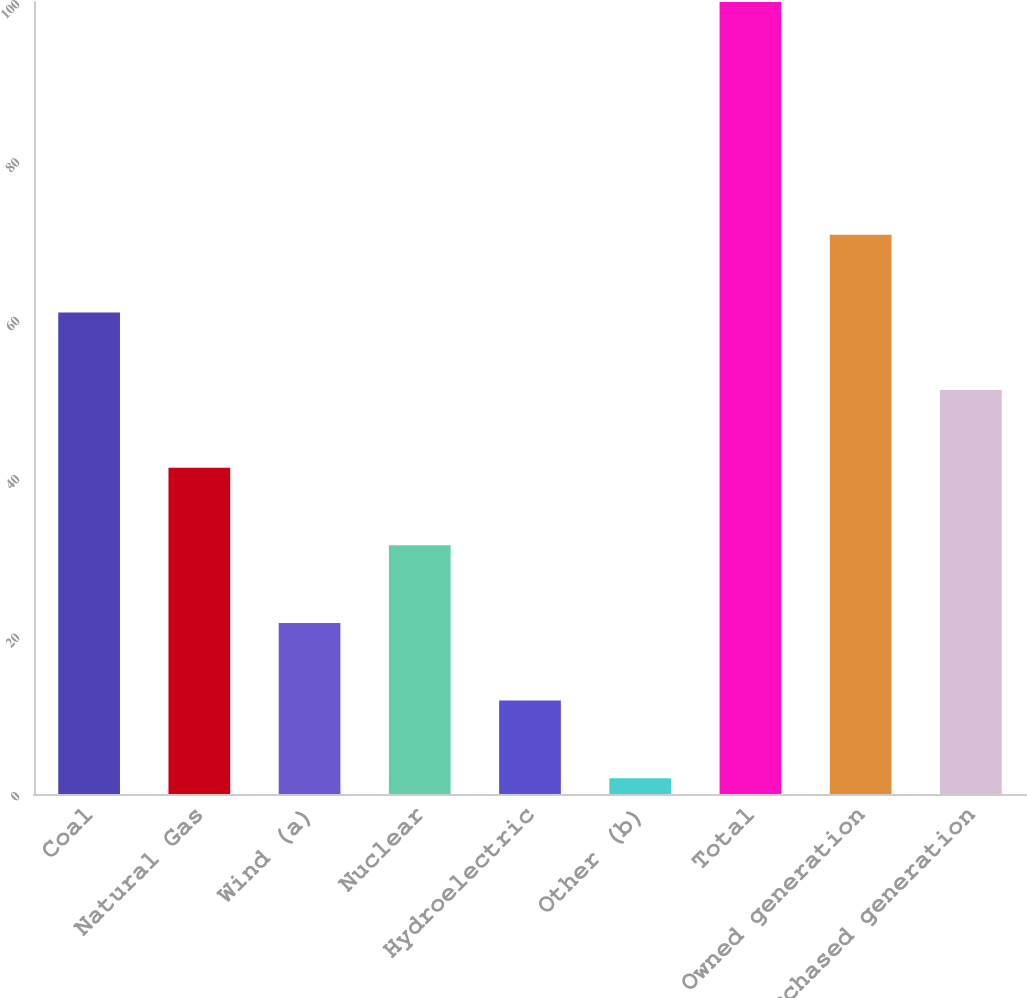Convert chart to OTSL. <chart><loc_0><loc_0><loc_500><loc_500><bar_chart><fcel>Coal<fcel>Natural Gas<fcel>Wind (a)<fcel>Nuclear<fcel>Hydroelectric<fcel>Other (b)<fcel>Total<fcel>Owned generation<fcel>Purchased generation<nl><fcel>60.8<fcel>41.2<fcel>21.6<fcel>31.4<fcel>11.8<fcel>2<fcel>100<fcel>70.6<fcel>51<nl></chart> 